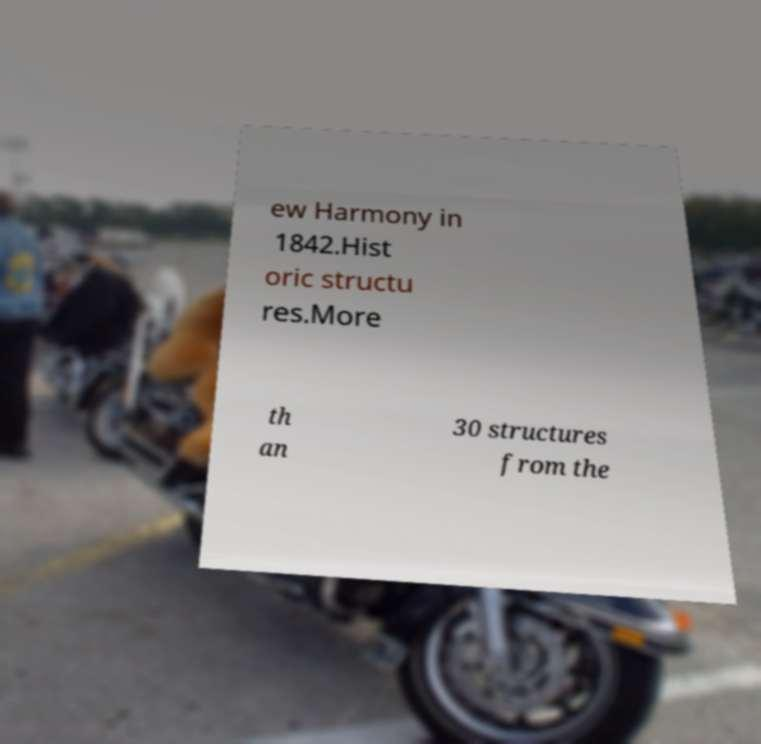I need the written content from this picture converted into text. Can you do that? ew Harmony in 1842.Hist oric structu res.More th an 30 structures from the 